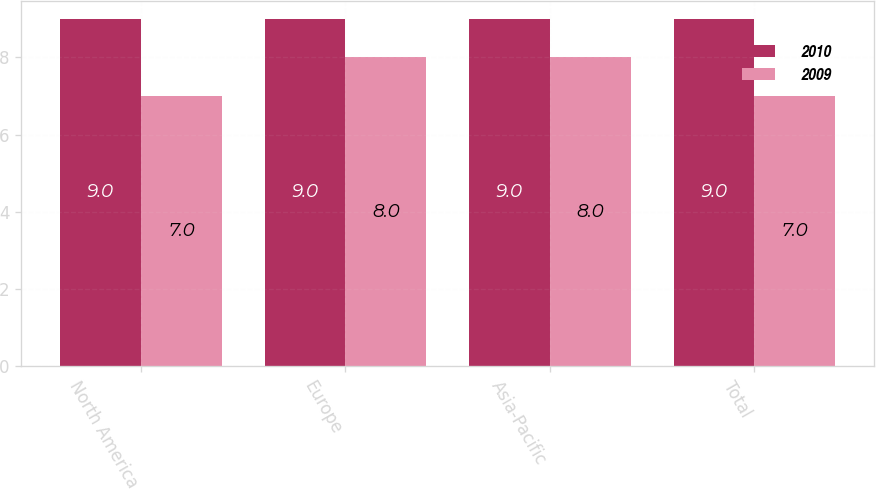Convert chart to OTSL. <chart><loc_0><loc_0><loc_500><loc_500><stacked_bar_chart><ecel><fcel>North America<fcel>Europe<fcel>Asia-Pacific<fcel>Total<nl><fcel>2010<fcel>9<fcel>9<fcel>9<fcel>9<nl><fcel>2009<fcel>7<fcel>8<fcel>8<fcel>7<nl></chart> 